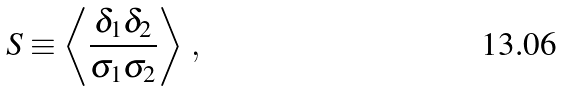Convert formula to latex. <formula><loc_0><loc_0><loc_500><loc_500>S \equiv \left < \frac { \delta _ { 1 } \delta _ { 2 } } { \sigma _ { 1 } \sigma _ { 2 } } \right > \, ,</formula> 